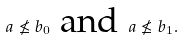Convert formula to latex. <formula><loc_0><loc_0><loc_500><loc_500>a \nleq b _ { 0 } \text { and } a \nleq b _ { 1 } .</formula> 